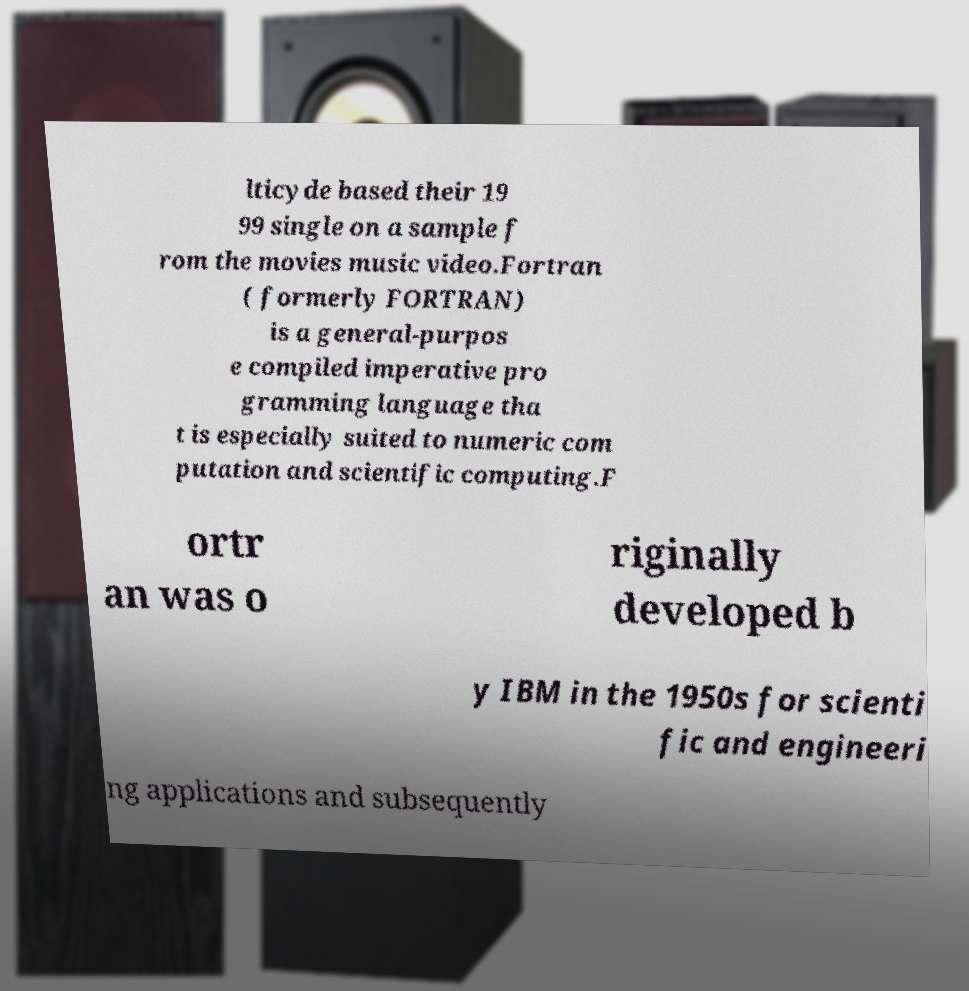Please read and relay the text visible in this image. What does it say? lticyde based their 19 99 single on a sample f rom the movies music video.Fortran ( formerly FORTRAN) is a general-purpos e compiled imperative pro gramming language tha t is especially suited to numeric com putation and scientific computing.F ortr an was o riginally developed b y IBM in the 1950s for scienti fic and engineeri ng applications and subsequently 